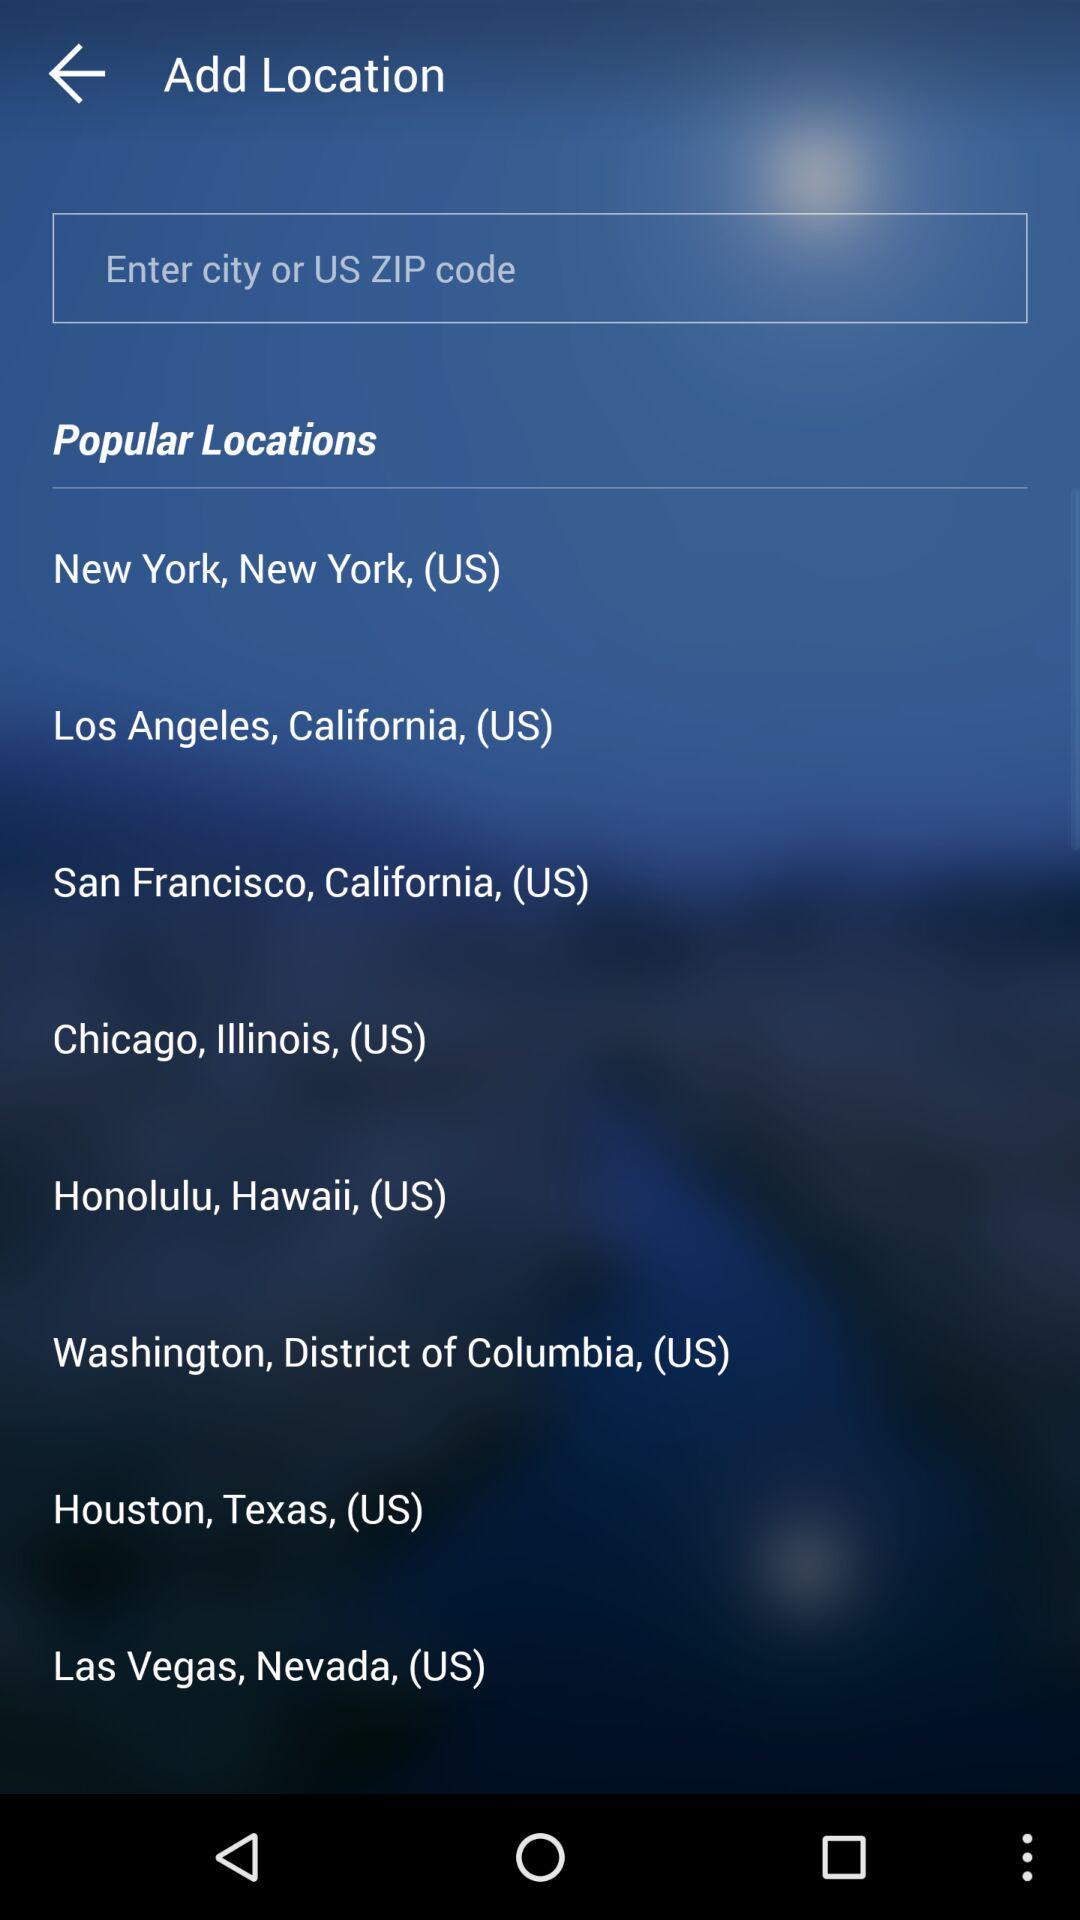How many more popular locations are there than text inputs?
Answer the question using a single word or phrase. 7 